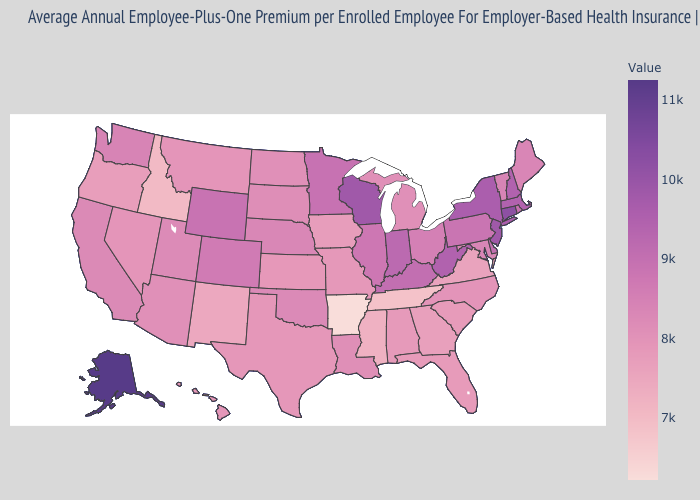Does West Virginia have a lower value than Alaska?
Keep it brief. Yes. Which states have the lowest value in the South?
Quick response, please. Arkansas. Does Arkansas have the lowest value in the USA?
Keep it brief. Yes. Does Arizona have the highest value in the USA?
Be succinct. No. Which states have the lowest value in the USA?
Give a very brief answer. Arkansas. Which states have the lowest value in the West?
Give a very brief answer. Idaho. Does Washington have a lower value than Idaho?
Answer briefly. No. Does Florida have the highest value in the South?
Answer briefly. No. 